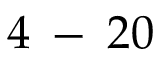<formula> <loc_0><loc_0><loc_500><loc_500>4 \, - \, 2 0 \</formula> 